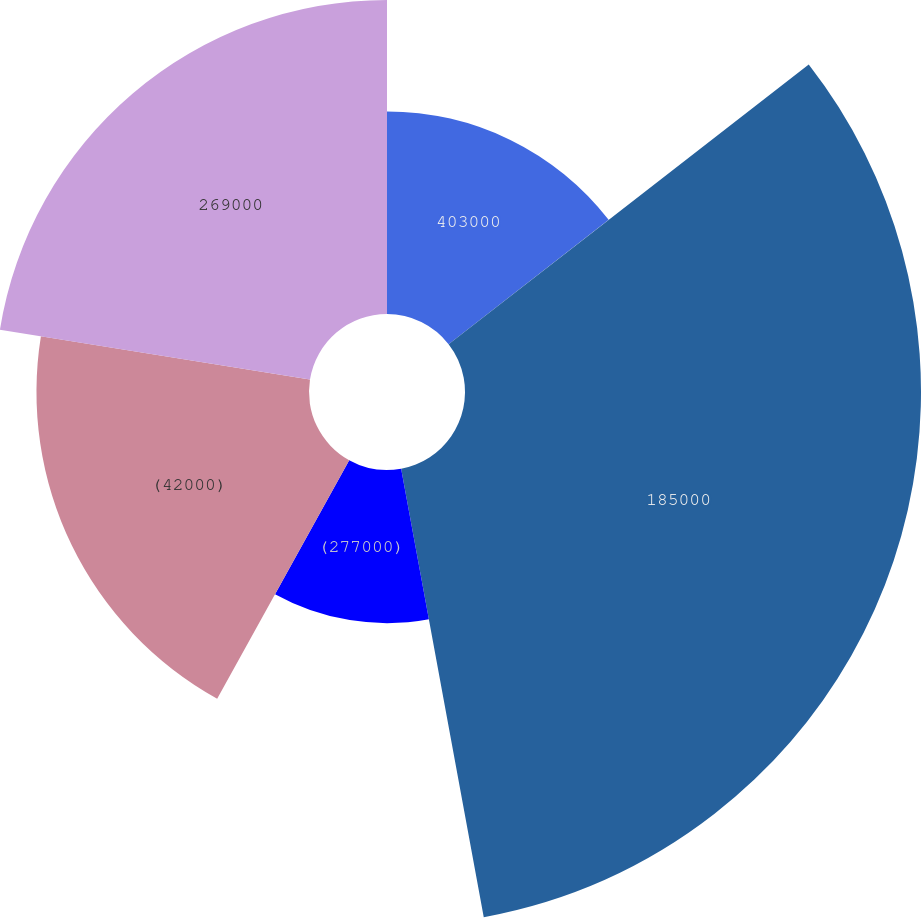Convert chart to OTSL. <chart><loc_0><loc_0><loc_500><loc_500><pie_chart><fcel>403000<fcel>185000<fcel>(277000)<fcel>(42000)<fcel>269000<nl><fcel>14.49%<fcel>32.61%<fcel>10.95%<fcel>19.49%<fcel>22.46%<nl></chart> 